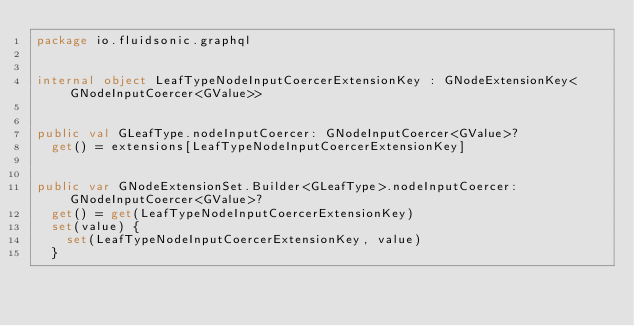Convert code to text. <code><loc_0><loc_0><loc_500><loc_500><_Kotlin_>package io.fluidsonic.graphql


internal object LeafTypeNodeInputCoercerExtensionKey : GNodeExtensionKey<GNodeInputCoercer<GValue>>


public val GLeafType.nodeInputCoercer: GNodeInputCoercer<GValue>?
	get() = extensions[LeafTypeNodeInputCoercerExtensionKey]


public var GNodeExtensionSet.Builder<GLeafType>.nodeInputCoercer: GNodeInputCoercer<GValue>?
	get() = get(LeafTypeNodeInputCoercerExtensionKey)
	set(value) {
		set(LeafTypeNodeInputCoercerExtensionKey, value)
	}
</code> 